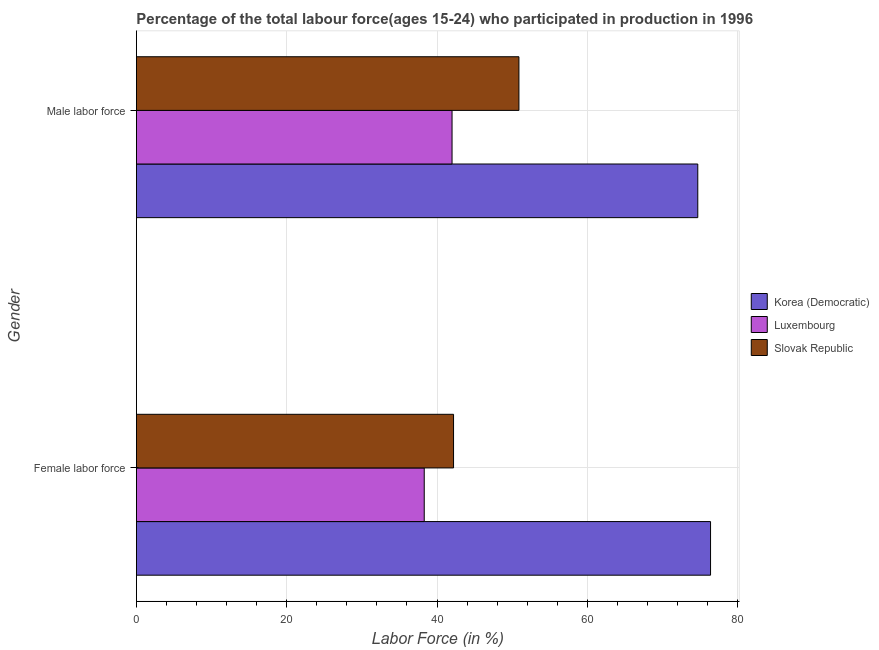How many different coloured bars are there?
Provide a succinct answer. 3. How many groups of bars are there?
Keep it short and to the point. 2. Are the number of bars per tick equal to the number of legend labels?
Your answer should be very brief. Yes. How many bars are there on the 1st tick from the bottom?
Offer a terse response. 3. What is the label of the 2nd group of bars from the top?
Keep it short and to the point. Female labor force. What is the percentage of male labour force in Korea (Democratic)?
Make the answer very short. 74.7. Across all countries, what is the maximum percentage of male labour force?
Offer a terse response. 74.7. Across all countries, what is the minimum percentage of female labor force?
Provide a succinct answer. 38.3. In which country was the percentage of female labor force maximum?
Make the answer very short. Korea (Democratic). In which country was the percentage of male labour force minimum?
Your answer should be compact. Luxembourg. What is the total percentage of female labor force in the graph?
Your answer should be compact. 156.9. What is the difference between the percentage of male labour force in Luxembourg and that in Korea (Democratic)?
Your answer should be compact. -32.7. What is the difference between the percentage of female labor force in Slovak Republic and the percentage of male labour force in Luxembourg?
Provide a succinct answer. 0.2. What is the average percentage of female labor force per country?
Make the answer very short. 52.3. What is the difference between the percentage of female labor force and percentage of male labour force in Slovak Republic?
Your answer should be very brief. -8.7. What is the ratio of the percentage of female labor force in Luxembourg to that in Korea (Democratic)?
Make the answer very short. 0.5. Is the percentage of female labor force in Slovak Republic less than that in Luxembourg?
Keep it short and to the point. No. What does the 3rd bar from the top in Female labor force represents?
Give a very brief answer. Korea (Democratic). What does the 1st bar from the bottom in Female labor force represents?
Offer a very short reply. Korea (Democratic). Are all the bars in the graph horizontal?
Keep it short and to the point. Yes. How many countries are there in the graph?
Your answer should be compact. 3. Are the values on the major ticks of X-axis written in scientific E-notation?
Offer a very short reply. No. Does the graph contain any zero values?
Offer a terse response. No. Does the graph contain grids?
Keep it short and to the point. Yes. Where does the legend appear in the graph?
Provide a succinct answer. Center right. How many legend labels are there?
Make the answer very short. 3. What is the title of the graph?
Offer a very short reply. Percentage of the total labour force(ages 15-24) who participated in production in 1996. Does "Guinea-Bissau" appear as one of the legend labels in the graph?
Give a very brief answer. No. What is the Labor Force (in %) of Korea (Democratic) in Female labor force?
Keep it short and to the point. 76.4. What is the Labor Force (in %) in Luxembourg in Female labor force?
Your answer should be very brief. 38.3. What is the Labor Force (in %) of Slovak Republic in Female labor force?
Provide a short and direct response. 42.2. What is the Labor Force (in %) of Korea (Democratic) in Male labor force?
Provide a succinct answer. 74.7. What is the Labor Force (in %) of Luxembourg in Male labor force?
Make the answer very short. 42. What is the Labor Force (in %) of Slovak Republic in Male labor force?
Ensure brevity in your answer.  50.9. Across all Gender, what is the maximum Labor Force (in %) of Korea (Democratic)?
Give a very brief answer. 76.4. Across all Gender, what is the maximum Labor Force (in %) of Slovak Republic?
Your answer should be compact. 50.9. Across all Gender, what is the minimum Labor Force (in %) of Korea (Democratic)?
Give a very brief answer. 74.7. Across all Gender, what is the minimum Labor Force (in %) in Luxembourg?
Offer a very short reply. 38.3. Across all Gender, what is the minimum Labor Force (in %) of Slovak Republic?
Offer a terse response. 42.2. What is the total Labor Force (in %) of Korea (Democratic) in the graph?
Your answer should be compact. 151.1. What is the total Labor Force (in %) of Luxembourg in the graph?
Keep it short and to the point. 80.3. What is the total Labor Force (in %) in Slovak Republic in the graph?
Your answer should be very brief. 93.1. What is the difference between the Labor Force (in %) in Slovak Republic in Female labor force and that in Male labor force?
Offer a terse response. -8.7. What is the difference between the Labor Force (in %) in Korea (Democratic) in Female labor force and the Labor Force (in %) in Luxembourg in Male labor force?
Provide a short and direct response. 34.4. What is the difference between the Labor Force (in %) in Korea (Democratic) in Female labor force and the Labor Force (in %) in Slovak Republic in Male labor force?
Give a very brief answer. 25.5. What is the difference between the Labor Force (in %) in Luxembourg in Female labor force and the Labor Force (in %) in Slovak Republic in Male labor force?
Keep it short and to the point. -12.6. What is the average Labor Force (in %) in Korea (Democratic) per Gender?
Give a very brief answer. 75.55. What is the average Labor Force (in %) in Luxembourg per Gender?
Offer a very short reply. 40.15. What is the average Labor Force (in %) in Slovak Republic per Gender?
Make the answer very short. 46.55. What is the difference between the Labor Force (in %) of Korea (Democratic) and Labor Force (in %) of Luxembourg in Female labor force?
Provide a succinct answer. 38.1. What is the difference between the Labor Force (in %) in Korea (Democratic) and Labor Force (in %) in Slovak Republic in Female labor force?
Offer a very short reply. 34.2. What is the difference between the Labor Force (in %) of Luxembourg and Labor Force (in %) of Slovak Republic in Female labor force?
Keep it short and to the point. -3.9. What is the difference between the Labor Force (in %) in Korea (Democratic) and Labor Force (in %) in Luxembourg in Male labor force?
Make the answer very short. 32.7. What is the difference between the Labor Force (in %) in Korea (Democratic) and Labor Force (in %) in Slovak Republic in Male labor force?
Provide a succinct answer. 23.8. What is the ratio of the Labor Force (in %) of Korea (Democratic) in Female labor force to that in Male labor force?
Ensure brevity in your answer.  1.02. What is the ratio of the Labor Force (in %) of Luxembourg in Female labor force to that in Male labor force?
Your answer should be compact. 0.91. What is the ratio of the Labor Force (in %) of Slovak Republic in Female labor force to that in Male labor force?
Your response must be concise. 0.83. What is the difference between the highest and the second highest Labor Force (in %) of Korea (Democratic)?
Your answer should be very brief. 1.7. What is the difference between the highest and the second highest Labor Force (in %) in Luxembourg?
Your answer should be very brief. 3.7. What is the difference between the highest and the second highest Labor Force (in %) of Slovak Republic?
Offer a very short reply. 8.7. What is the difference between the highest and the lowest Labor Force (in %) in Luxembourg?
Your answer should be compact. 3.7. 